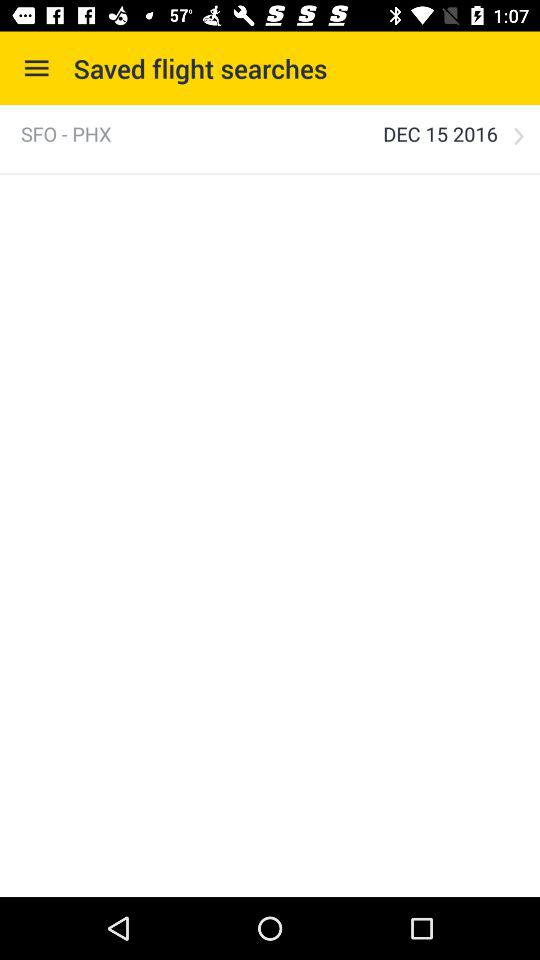What's the saved schedule date of the flight from San Francisco to Phoenix? The saved schedule date is December 15, 2016. 